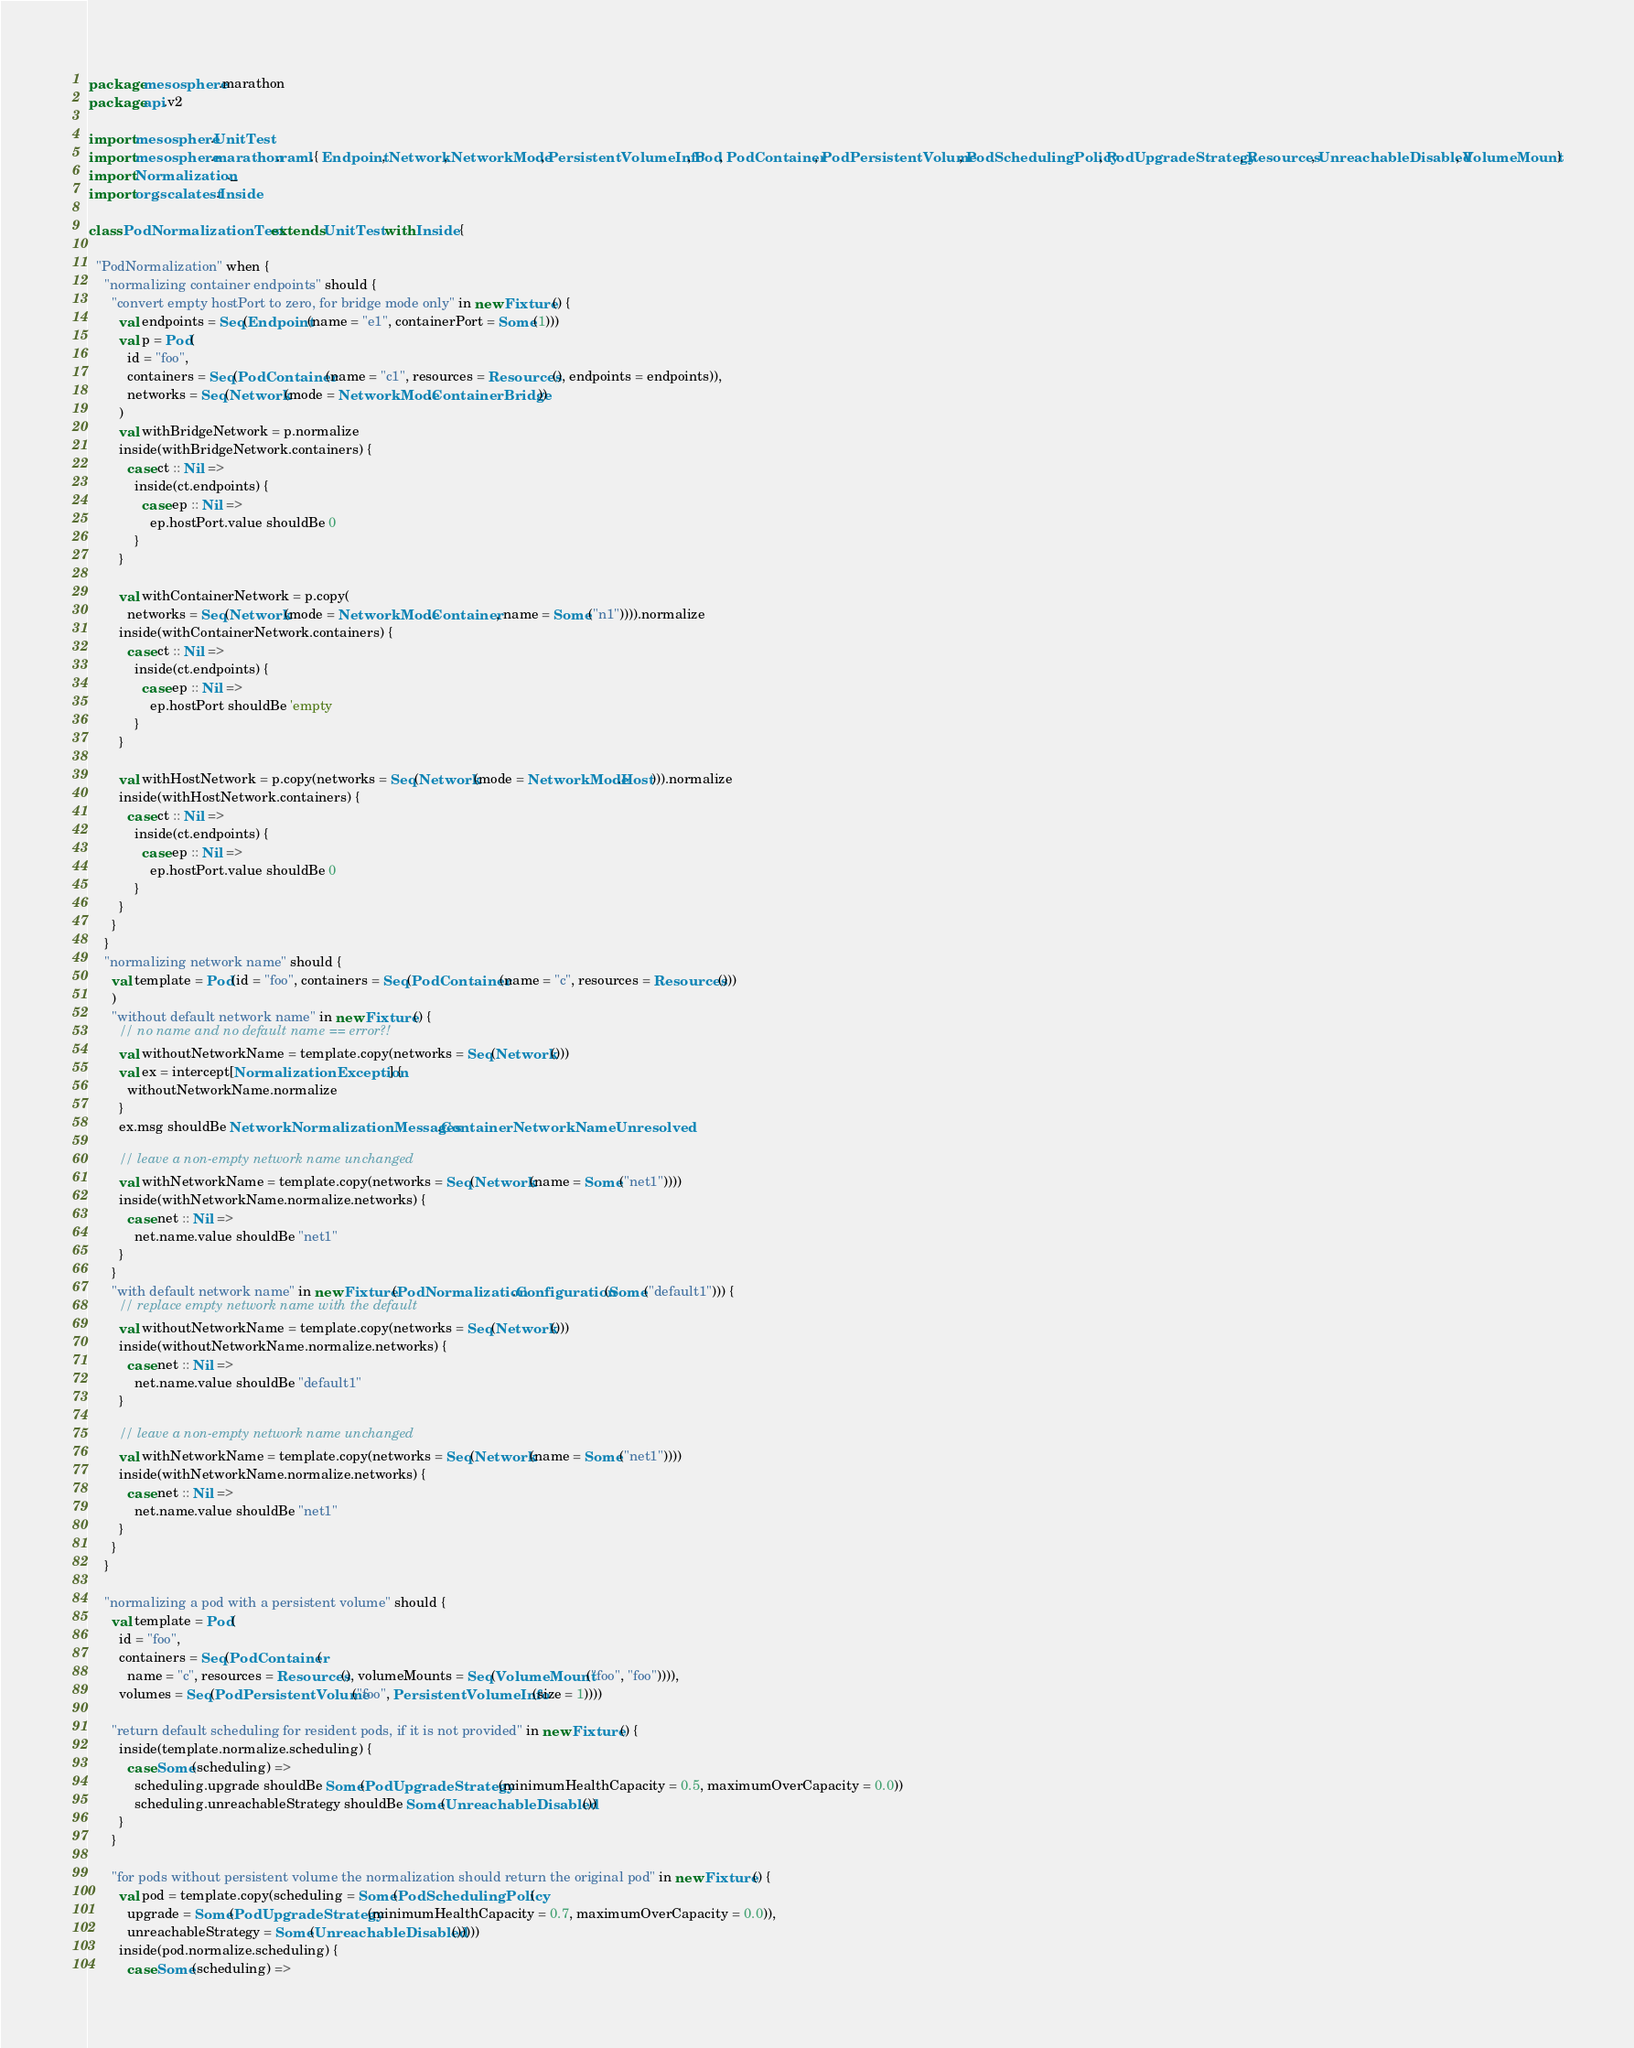Convert code to text. <code><loc_0><loc_0><loc_500><loc_500><_Scala_>package mesosphere.marathon
package api.v2

import mesosphere.UnitTest
import mesosphere.marathon.raml.{ Endpoint, Network, NetworkMode, PersistentVolumeInfo, Pod, PodContainer, PodPersistentVolume, PodSchedulingPolicy, PodUpgradeStrategy, Resources, UnreachableDisabled, VolumeMount }
import Normalization._
import org.scalatest.Inside

class PodNormalizationTest extends UnitTest with Inside {

  "PodNormalization" when {
    "normalizing container endpoints" should {
      "convert empty hostPort to zero, for bridge mode only" in new Fixture() {
        val endpoints = Seq(Endpoint(name = "e1", containerPort = Some(1)))
        val p = Pod(
          id = "foo",
          containers = Seq(PodContainer(name = "c1", resources = Resources(), endpoints = endpoints)),
          networks = Seq(Network(mode = NetworkMode.ContainerBridge))
        )
        val withBridgeNetwork = p.normalize
        inside(withBridgeNetwork.containers) {
          case ct :: Nil =>
            inside(ct.endpoints) {
              case ep :: Nil =>
                ep.hostPort.value shouldBe 0
            }
        }

        val withContainerNetwork = p.copy(
          networks = Seq(Network(mode = NetworkMode.Container, name = Some("n1")))).normalize
        inside(withContainerNetwork.containers) {
          case ct :: Nil =>
            inside(ct.endpoints) {
              case ep :: Nil =>
                ep.hostPort shouldBe 'empty
            }
        }

        val withHostNetwork = p.copy(networks = Seq(Network(mode = NetworkMode.Host))).normalize
        inside(withHostNetwork.containers) {
          case ct :: Nil =>
            inside(ct.endpoints) {
              case ep :: Nil =>
                ep.hostPort.value shouldBe 0
            }
        }
      }
    }
    "normalizing network name" should {
      val template = Pod(id = "foo", containers = Seq(PodContainer(name = "c", resources = Resources()))
      )
      "without default network name" in new Fixture() {
        // no name and no default name == error?!
        val withoutNetworkName = template.copy(networks = Seq(Network()))
        val ex = intercept[NormalizationException] {
          withoutNetworkName.normalize
        }
        ex.msg shouldBe NetworkNormalizationMessages.ContainerNetworkNameUnresolved

        // leave a non-empty network name unchanged
        val withNetworkName = template.copy(networks = Seq(Network(name = Some("net1"))))
        inside(withNetworkName.normalize.networks) {
          case net :: Nil =>
            net.name.value shouldBe "net1"
        }
      }
      "with default network name" in new Fixture(PodNormalization.Configuration(Some("default1"))) {
        // replace empty network name with the default
        val withoutNetworkName = template.copy(networks = Seq(Network()))
        inside(withoutNetworkName.normalize.networks) {
          case net :: Nil =>
            net.name.value shouldBe "default1"
        }

        // leave a non-empty network name unchanged
        val withNetworkName = template.copy(networks = Seq(Network(name = Some("net1"))))
        inside(withNetworkName.normalize.networks) {
          case net :: Nil =>
            net.name.value shouldBe "net1"
        }
      }
    }

    "normalizing a pod with a persistent volume" should {
      val template = Pod(
        id = "foo",
        containers = Seq(PodContainer(
          name = "c", resources = Resources(), volumeMounts = Seq(VolumeMount("foo", "foo")))),
        volumes = Seq(PodPersistentVolume("foo", PersistentVolumeInfo(size = 1))))

      "return default scheduling for resident pods, if it is not provided" in new Fixture() {
        inside(template.normalize.scheduling) {
          case Some(scheduling) =>
            scheduling.upgrade shouldBe Some(PodUpgradeStrategy(minimumHealthCapacity = 0.5, maximumOverCapacity = 0.0))
            scheduling.unreachableStrategy shouldBe Some(UnreachableDisabled())
        }
      }

      "for pods without persistent volume the normalization should return the original pod" in new Fixture() {
        val pod = template.copy(scheduling = Some(PodSchedulingPolicy(
          upgrade = Some(PodUpgradeStrategy(minimumHealthCapacity = 0.7, maximumOverCapacity = 0.0)),
          unreachableStrategy = Some(UnreachableDisabled()))))
        inside(pod.normalize.scheduling) {
          case Some(scheduling) =></code> 